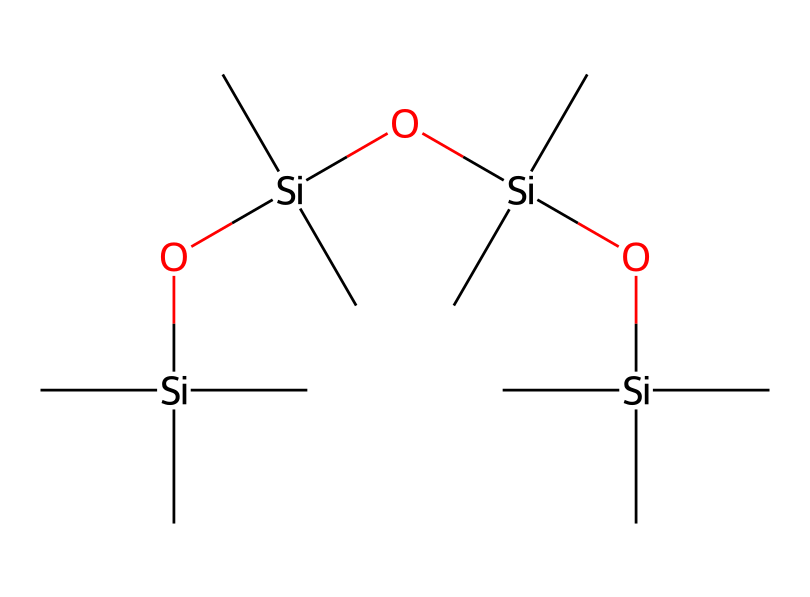How many silicon atoms are present in the chemical? The chemical structure shows that there are three distinct silicon (Si) central atoms, each represented in the siloxane backbone linked by oxygen atoms.
Answer: three What is the general functional group present in this compound? The siloxane structure indicates that the chemical contains siloxane linkages (-Si-O-Si-) formed by alternating silicon and oxygen atoms, characteristic of organosilicon compounds.
Answer: siloxane How many carbon atoms are branched off from each silicon atom? Each silicon atom in this structure has three carbon (C) groups attached to it as evident from the branching around the silicon atoms.
Answer: three What type of bonding is primarily present in this compound? The primary bonding in the molecule is covalent, characterized by the strong bond formation between silicon and carbon atoms as well as between silicon and oxygen atoms.
Answer: covalent What property makes siloxane compounds suitable for non-stick applications in cookware? The chemical's structure provides low surface energy due to the siloxane linkages, which reduces adhesion, making them ideal for non-stick coatings.
Answer: low surface energy How many oxygen atoms are in the chemical structure? The chemical structure shows that there are four oxygen (O) atoms present, each linking the silicon atoms together in the siloxane framework.
Answer: four 